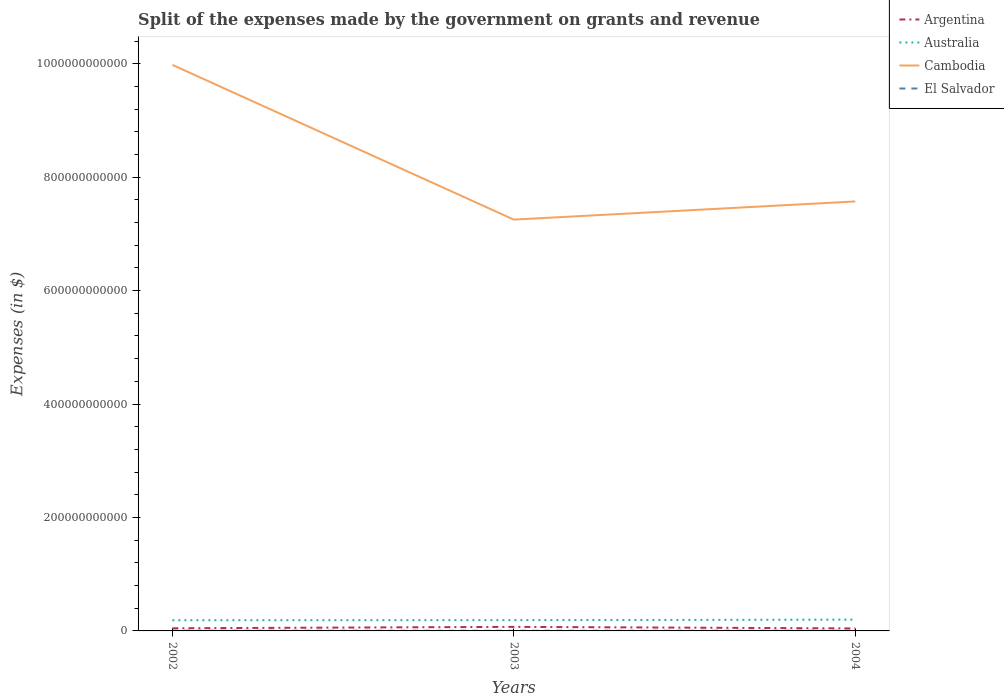How many different coloured lines are there?
Provide a succinct answer. 4. Across all years, what is the maximum expenses made by the government on grants and revenue in El Salvador?
Provide a succinct answer. 2.89e+08. In which year was the expenses made by the government on grants and revenue in Cambodia maximum?
Keep it short and to the point. 2003. What is the total expenses made by the government on grants and revenue in Argentina in the graph?
Keep it short and to the point. 2.76e+09. What is the difference between the highest and the second highest expenses made by the government on grants and revenue in Argentina?
Your answer should be very brief. 2.76e+09. Is the expenses made by the government on grants and revenue in Cambodia strictly greater than the expenses made by the government on grants and revenue in El Salvador over the years?
Your answer should be compact. No. How many years are there in the graph?
Your answer should be compact. 3. What is the difference between two consecutive major ticks on the Y-axis?
Keep it short and to the point. 2.00e+11. Are the values on the major ticks of Y-axis written in scientific E-notation?
Provide a short and direct response. No. Does the graph contain any zero values?
Offer a terse response. No. How many legend labels are there?
Give a very brief answer. 4. How are the legend labels stacked?
Your response must be concise. Vertical. What is the title of the graph?
Keep it short and to the point. Split of the expenses made by the government on grants and revenue. What is the label or title of the Y-axis?
Make the answer very short. Expenses (in $). What is the Expenses (in $) in Argentina in 2002?
Your answer should be very brief. 4.66e+09. What is the Expenses (in $) of Australia in 2002?
Keep it short and to the point. 1.88e+1. What is the Expenses (in $) of Cambodia in 2002?
Ensure brevity in your answer.  9.98e+11. What is the Expenses (in $) in El Salvador in 2002?
Keep it short and to the point. 4.32e+08. What is the Expenses (in $) in Argentina in 2003?
Your response must be concise. 7.15e+09. What is the Expenses (in $) of Australia in 2003?
Your response must be concise. 1.90e+1. What is the Expenses (in $) of Cambodia in 2003?
Make the answer very short. 7.25e+11. What is the Expenses (in $) in El Salvador in 2003?
Your response must be concise. 2.89e+08. What is the Expenses (in $) of Argentina in 2004?
Offer a terse response. 4.39e+09. What is the Expenses (in $) of Australia in 2004?
Your answer should be very brief. 1.99e+1. What is the Expenses (in $) of Cambodia in 2004?
Keep it short and to the point. 7.57e+11. What is the Expenses (in $) in El Salvador in 2004?
Keep it short and to the point. 3.98e+08. Across all years, what is the maximum Expenses (in $) in Argentina?
Your answer should be compact. 7.15e+09. Across all years, what is the maximum Expenses (in $) of Australia?
Your answer should be very brief. 1.99e+1. Across all years, what is the maximum Expenses (in $) of Cambodia?
Your answer should be compact. 9.98e+11. Across all years, what is the maximum Expenses (in $) of El Salvador?
Your answer should be compact. 4.32e+08. Across all years, what is the minimum Expenses (in $) of Argentina?
Your response must be concise. 4.39e+09. Across all years, what is the minimum Expenses (in $) of Australia?
Your answer should be very brief. 1.88e+1. Across all years, what is the minimum Expenses (in $) of Cambodia?
Your response must be concise. 7.25e+11. Across all years, what is the minimum Expenses (in $) of El Salvador?
Make the answer very short. 2.89e+08. What is the total Expenses (in $) of Argentina in the graph?
Your answer should be compact. 1.62e+1. What is the total Expenses (in $) of Australia in the graph?
Ensure brevity in your answer.  5.77e+1. What is the total Expenses (in $) of Cambodia in the graph?
Make the answer very short. 2.48e+12. What is the total Expenses (in $) of El Salvador in the graph?
Give a very brief answer. 1.12e+09. What is the difference between the Expenses (in $) of Argentina in 2002 and that in 2003?
Provide a succinct answer. -2.49e+09. What is the difference between the Expenses (in $) of Australia in 2002 and that in 2003?
Keep it short and to the point. -1.58e+08. What is the difference between the Expenses (in $) of Cambodia in 2002 and that in 2003?
Make the answer very short. 2.73e+11. What is the difference between the Expenses (in $) in El Salvador in 2002 and that in 2003?
Provide a succinct answer. 1.43e+08. What is the difference between the Expenses (in $) of Argentina in 2002 and that in 2004?
Your answer should be very brief. 2.69e+08. What is the difference between the Expenses (in $) of Australia in 2002 and that in 2004?
Your answer should be very brief. -1.08e+09. What is the difference between the Expenses (in $) in Cambodia in 2002 and that in 2004?
Your answer should be compact. 2.41e+11. What is the difference between the Expenses (in $) in El Salvador in 2002 and that in 2004?
Your answer should be very brief. 3.33e+07. What is the difference between the Expenses (in $) in Argentina in 2003 and that in 2004?
Give a very brief answer. 2.76e+09. What is the difference between the Expenses (in $) in Australia in 2003 and that in 2004?
Make the answer very short. -9.24e+08. What is the difference between the Expenses (in $) of Cambodia in 2003 and that in 2004?
Your response must be concise. -3.20e+1. What is the difference between the Expenses (in $) in El Salvador in 2003 and that in 2004?
Your response must be concise. -1.09e+08. What is the difference between the Expenses (in $) in Argentina in 2002 and the Expenses (in $) in Australia in 2003?
Ensure brevity in your answer.  -1.43e+1. What is the difference between the Expenses (in $) of Argentina in 2002 and the Expenses (in $) of Cambodia in 2003?
Your response must be concise. -7.21e+11. What is the difference between the Expenses (in $) in Argentina in 2002 and the Expenses (in $) in El Salvador in 2003?
Make the answer very short. 4.37e+09. What is the difference between the Expenses (in $) of Australia in 2002 and the Expenses (in $) of Cambodia in 2003?
Keep it short and to the point. -7.06e+11. What is the difference between the Expenses (in $) of Australia in 2002 and the Expenses (in $) of El Salvador in 2003?
Offer a terse response. 1.85e+1. What is the difference between the Expenses (in $) in Cambodia in 2002 and the Expenses (in $) in El Salvador in 2003?
Ensure brevity in your answer.  9.98e+11. What is the difference between the Expenses (in $) of Argentina in 2002 and the Expenses (in $) of Australia in 2004?
Your answer should be very brief. -1.53e+1. What is the difference between the Expenses (in $) in Argentina in 2002 and the Expenses (in $) in Cambodia in 2004?
Your response must be concise. -7.53e+11. What is the difference between the Expenses (in $) in Argentina in 2002 and the Expenses (in $) in El Salvador in 2004?
Provide a succinct answer. 4.26e+09. What is the difference between the Expenses (in $) of Australia in 2002 and the Expenses (in $) of Cambodia in 2004?
Keep it short and to the point. -7.38e+11. What is the difference between the Expenses (in $) in Australia in 2002 and the Expenses (in $) in El Salvador in 2004?
Offer a terse response. 1.84e+1. What is the difference between the Expenses (in $) in Cambodia in 2002 and the Expenses (in $) in El Salvador in 2004?
Keep it short and to the point. 9.98e+11. What is the difference between the Expenses (in $) of Argentina in 2003 and the Expenses (in $) of Australia in 2004?
Give a very brief answer. -1.28e+1. What is the difference between the Expenses (in $) of Argentina in 2003 and the Expenses (in $) of Cambodia in 2004?
Your answer should be very brief. -7.50e+11. What is the difference between the Expenses (in $) in Argentina in 2003 and the Expenses (in $) in El Salvador in 2004?
Offer a very short reply. 6.75e+09. What is the difference between the Expenses (in $) of Australia in 2003 and the Expenses (in $) of Cambodia in 2004?
Ensure brevity in your answer.  -7.38e+11. What is the difference between the Expenses (in $) of Australia in 2003 and the Expenses (in $) of El Salvador in 2004?
Give a very brief answer. 1.86e+1. What is the difference between the Expenses (in $) in Cambodia in 2003 and the Expenses (in $) in El Salvador in 2004?
Ensure brevity in your answer.  7.25e+11. What is the average Expenses (in $) in Argentina per year?
Provide a succinct answer. 5.40e+09. What is the average Expenses (in $) of Australia per year?
Ensure brevity in your answer.  1.92e+1. What is the average Expenses (in $) of Cambodia per year?
Your answer should be very brief. 8.27e+11. What is the average Expenses (in $) in El Salvador per year?
Provide a short and direct response. 3.73e+08. In the year 2002, what is the difference between the Expenses (in $) in Argentina and Expenses (in $) in Australia?
Make the answer very short. -1.42e+1. In the year 2002, what is the difference between the Expenses (in $) of Argentina and Expenses (in $) of Cambodia?
Keep it short and to the point. -9.93e+11. In the year 2002, what is the difference between the Expenses (in $) in Argentina and Expenses (in $) in El Salvador?
Ensure brevity in your answer.  4.23e+09. In the year 2002, what is the difference between the Expenses (in $) in Australia and Expenses (in $) in Cambodia?
Give a very brief answer. -9.79e+11. In the year 2002, what is the difference between the Expenses (in $) in Australia and Expenses (in $) in El Salvador?
Provide a short and direct response. 1.84e+1. In the year 2002, what is the difference between the Expenses (in $) in Cambodia and Expenses (in $) in El Salvador?
Ensure brevity in your answer.  9.98e+11. In the year 2003, what is the difference between the Expenses (in $) of Argentina and Expenses (in $) of Australia?
Your answer should be compact. -1.18e+1. In the year 2003, what is the difference between the Expenses (in $) in Argentina and Expenses (in $) in Cambodia?
Your answer should be very brief. -7.18e+11. In the year 2003, what is the difference between the Expenses (in $) in Argentina and Expenses (in $) in El Salvador?
Offer a terse response. 6.86e+09. In the year 2003, what is the difference between the Expenses (in $) of Australia and Expenses (in $) of Cambodia?
Your answer should be compact. -7.06e+11. In the year 2003, what is the difference between the Expenses (in $) in Australia and Expenses (in $) in El Salvador?
Provide a succinct answer. 1.87e+1. In the year 2003, what is the difference between the Expenses (in $) of Cambodia and Expenses (in $) of El Salvador?
Make the answer very short. 7.25e+11. In the year 2004, what is the difference between the Expenses (in $) of Argentina and Expenses (in $) of Australia?
Provide a succinct answer. -1.55e+1. In the year 2004, what is the difference between the Expenses (in $) of Argentina and Expenses (in $) of Cambodia?
Ensure brevity in your answer.  -7.53e+11. In the year 2004, what is the difference between the Expenses (in $) of Argentina and Expenses (in $) of El Salvador?
Ensure brevity in your answer.  3.99e+09. In the year 2004, what is the difference between the Expenses (in $) of Australia and Expenses (in $) of Cambodia?
Ensure brevity in your answer.  -7.37e+11. In the year 2004, what is the difference between the Expenses (in $) of Australia and Expenses (in $) of El Salvador?
Offer a very short reply. 1.95e+1. In the year 2004, what is the difference between the Expenses (in $) of Cambodia and Expenses (in $) of El Salvador?
Your response must be concise. 7.57e+11. What is the ratio of the Expenses (in $) in Argentina in 2002 to that in 2003?
Give a very brief answer. 0.65. What is the ratio of the Expenses (in $) in Cambodia in 2002 to that in 2003?
Give a very brief answer. 1.38. What is the ratio of the Expenses (in $) in El Salvador in 2002 to that in 2003?
Your answer should be very brief. 1.49. What is the ratio of the Expenses (in $) of Argentina in 2002 to that in 2004?
Your answer should be compact. 1.06. What is the ratio of the Expenses (in $) in Australia in 2002 to that in 2004?
Your response must be concise. 0.95. What is the ratio of the Expenses (in $) of Cambodia in 2002 to that in 2004?
Your answer should be very brief. 1.32. What is the ratio of the Expenses (in $) in El Salvador in 2002 to that in 2004?
Ensure brevity in your answer.  1.08. What is the ratio of the Expenses (in $) of Argentina in 2003 to that in 2004?
Keep it short and to the point. 1.63. What is the ratio of the Expenses (in $) of Australia in 2003 to that in 2004?
Keep it short and to the point. 0.95. What is the ratio of the Expenses (in $) in Cambodia in 2003 to that in 2004?
Give a very brief answer. 0.96. What is the ratio of the Expenses (in $) of El Salvador in 2003 to that in 2004?
Your response must be concise. 0.73. What is the difference between the highest and the second highest Expenses (in $) of Argentina?
Keep it short and to the point. 2.49e+09. What is the difference between the highest and the second highest Expenses (in $) in Australia?
Make the answer very short. 9.24e+08. What is the difference between the highest and the second highest Expenses (in $) in Cambodia?
Keep it short and to the point. 2.41e+11. What is the difference between the highest and the second highest Expenses (in $) in El Salvador?
Your answer should be very brief. 3.33e+07. What is the difference between the highest and the lowest Expenses (in $) of Argentina?
Your answer should be very brief. 2.76e+09. What is the difference between the highest and the lowest Expenses (in $) of Australia?
Your response must be concise. 1.08e+09. What is the difference between the highest and the lowest Expenses (in $) of Cambodia?
Keep it short and to the point. 2.73e+11. What is the difference between the highest and the lowest Expenses (in $) of El Salvador?
Your response must be concise. 1.43e+08. 